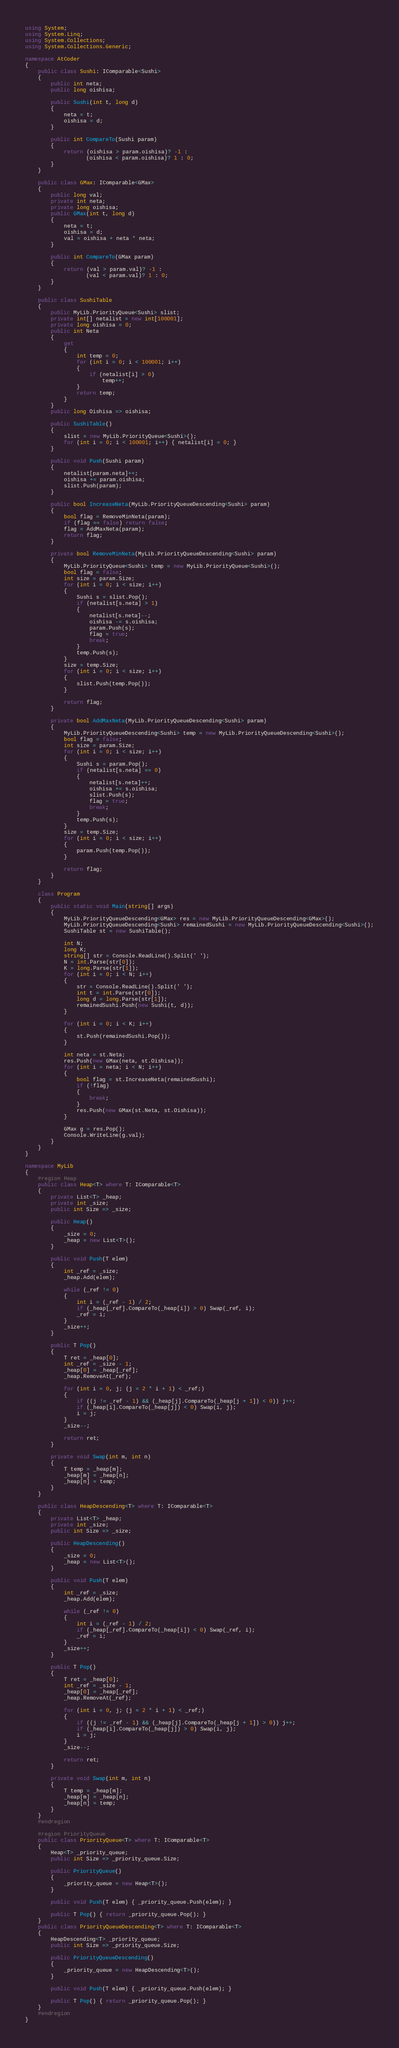Convert code to text. <code><loc_0><loc_0><loc_500><loc_500><_C#_>using System;
using System.Linq;
using System.Collections;
using System.Collections.Generic;

namespace AtCoder
{
    public class Sushi: IComparable<Sushi>
    {
        public int neta;
        public long oishisa;

        public Sushi(int t, long d)
        {
            neta = t;
            oishisa = d;
        }

        public int CompareTo(Sushi param)
        {
            return (oishisa > param.oishisa)? -1 :
                   (oishisa < param.oishisa)? 1 : 0;
        }
    }

    public class GMax: IComparable<GMax>
    {
        public long val;
        private int neta;
        private long oishisa;
        public GMax(int t, long d)
        {
            neta = t;
            oishisa = d;
            val = oishisa + neta * neta;
        }

        public int CompareTo(GMax param)
        {
            return (val > param.val)? -1 :
                   (val < param.val)? 1 : 0;
        }
    }

    public class SushiTable
    {
        public MyLib.PriorityQueue<Sushi> slist;
        private int[] netalist = new int[100001];
        private long oishisa = 0;
        public int Neta
        {
            get
            {
                int temp = 0;
                for (int i = 0; i < 100001; i++)
                {
                    if (netalist[i] > 0)
                        temp++;
                }
                return temp;
            }
        }
        public long Oishisa => oishisa;

        public SushiTable()
        {
            slist = new MyLib.PriorityQueue<Sushi>();
            for (int i = 0; i < 100001; i++) { netalist[i] = 0; }
        }

        public void Push(Sushi param)
        {
            netalist[param.neta]++;
            oishisa += param.oishisa;
            slist.Push(param);
        }

        public bool IncreaseNeta(MyLib.PriorityQueueDescending<Sushi> param)
        {
            bool flag = RemoveMinNeta(param);
            if (flag == false) return false;
            flag = AddMaxNeta(param);
            return flag;
        }

        private bool RemoveMinNeta(MyLib.PriorityQueueDescending<Sushi> param)
        {
            MyLib.PriorityQueue<Sushi> temp = new MyLib.PriorityQueue<Sushi>();
            bool flag = false;
            int size = param.Size;
            for (int i = 0; i < size; i++)
            {
                Sushi s = slist.Pop();
                if (netalist[s.neta] > 1)
                {
                    netalist[s.neta]--;
                    oishisa -= s.oishisa;
                    param.Push(s);
                    flag = true;
                    break;
                }
                temp.Push(s);
            }
            size = temp.Size;
            for (int i = 0; i < size; i++)
            {
                slist.Push(temp.Pop());
            }

            return flag;
        }

        private bool AddMaxNeta(MyLib.PriorityQueueDescending<Sushi> param)
        {
            MyLib.PriorityQueueDescending<Sushi> temp = new MyLib.PriorityQueueDescending<Sushi>();
            bool flag = false;
            int size = param.Size;
            for (int i = 0; i < size; i++)
            {
                Sushi s = param.Pop();
                if (netalist[s.neta] == 0)
                {
                    netalist[s.neta]++;
                    oishisa += s.oishisa;
                    slist.Push(s);
                    flag = true;
                    break;
                }
                temp.Push(s);
            }
            size = temp.Size;
            for (int i = 0; i < size; i++)
            {
                param.Push(temp.Pop());
            }

            return flag;
        }
    }

    class Program
    {
        public static void Main(string[] args)
        {
            MyLib.PriorityQueueDescending<GMax> res = new MyLib.PriorityQueueDescending<GMax>();
            MyLib.PriorityQueueDescending<Sushi> remainedSushi = new MyLib.PriorityQueueDescending<Sushi>();
            SushiTable st = new SushiTable();

            int N;
            long K;
            string[] str = Console.ReadLine().Split(' ');
            N = int.Parse(str[0]);
            K = long.Parse(str[1]);
            for (int i = 0; i < N; i++)
            {
                str = Console.ReadLine().Split(' ');
                int t = int.Parse(str[0]);
                long d = long.Parse(str[1]);
                remainedSushi.Push(new Sushi(t, d));
            }

            for (int i = 0; i < K; i++)
            {
                st.Push(remainedSushi.Pop());
            }

            int neta = st.Neta;
            res.Push(new GMax(neta, st.Oishisa));
            for (int i = neta; i < N; i++)
            {
                bool flag = st.IncreaseNeta(remainedSushi);
                if (!flag)
                {
                    break;
                }
                res.Push(new GMax(st.Neta, st.Oishisa));
            }

            GMax g = res.Pop();
            Console.WriteLine(g.val);
        }
    }
}

namespace MyLib
{
    #region Heap
    public class Heap<T> where T: IComparable<T>
    {
        private List<T> _heap;
        private int _size;
        public int Size => _size;

        public Heap()
        {
            _size = 0;
            _heap = new List<T>();
        }

        public void Push(T elem)
        {
            int _ref = _size;
            _heap.Add(elem);

            while (_ref != 0)
            {
                int i = (_ref - 1) / 2;
                if (_heap[_ref].CompareTo(_heap[i]) > 0) Swap(_ref, i);
                _ref = i;
            }
            _size++;
        }

        public T Pop()
        {
            T ret = _heap[0];
            int _ref = _size - 1;
            _heap[0] = _heap[_ref];
            _heap.RemoveAt(_ref);

            for (int i = 0, j; (j = 2 * i + 1) < _ref;)
            {
                if ((j != _ref - 1) && (_heap[j].CompareTo(_heap[j + 1]) < 0)) j++;
                if (_heap[i].CompareTo(_heap[j]) < 0) Swap(i, j);
                i = j;
            }
            _size--;

            return ret;
        }

        private void Swap(int m, int n)
        {
            T temp = _heap[m];
            _heap[m] = _heap[n];
            _heap[n] = temp;
        }
    }

    public class HeapDescending<T> where T: IComparable<T>
    {
        private List<T> _heap;
        private int _size;
        public int Size => _size;

        public HeapDescending()
        {
            _size = 0;
            _heap = new List<T>();
        }

        public void Push(T elem)
        {
            int _ref = _size;
            _heap.Add(elem);

            while (_ref != 0)
            {
                int i = (_ref - 1) / 2;
                if (_heap[_ref].CompareTo(_heap[i]) < 0) Swap(_ref, i);
                _ref = i;
            }
            _size++;
        }

        public T Pop()
        {
            T ret = _heap[0];
            int _ref = _size - 1;
            _heap[0] = _heap[_ref];
            _heap.RemoveAt(_ref);

            for (int i = 0, j; (j = 2 * i + 1) < _ref;)
            {
                if ((j != _ref - 1) && (_heap[j].CompareTo(_heap[j + 1]) > 0)) j++;
                if (_heap[i].CompareTo(_heap[j]) > 0) Swap(i, j);
                i = j;
            }
            _size--;

            return ret;
        }

        private void Swap(int m, int n)
        {
            T temp = _heap[m];
            _heap[m] = _heap[n];
            _heap[n] = temp;
        }
    }
    #endregion

    #region PriorityQueue
    public class PriorityQueue<T> where T: IComparable<T>
    {
        Heap<T> _priority_queue;
        public int Size => _priority_queue.Size;

        public PriorityQueue()
        {
            _priority_queue = new Heap<T>();
        }

        public void Push(T elem) { _priority_queue.Push(elem); }

        public T Pop() { return _priority_queue.Pop(); }
    }
    public class PriorityQueueDescending<T> where T: IComparable<T>
    {
        HeapDescending<T> _priority_queue;
        public int Size => _priority_queue.Size;

        public PriorityQueueDescending()
        {
            _priority_queue = new HeapDescending<T>();
        }

        public void Push(T elem) { _priority_queue.Push(elem); }

        public T Pop() { return _priority_queue.Pop(); }
    }
    #endregion
}</code> 